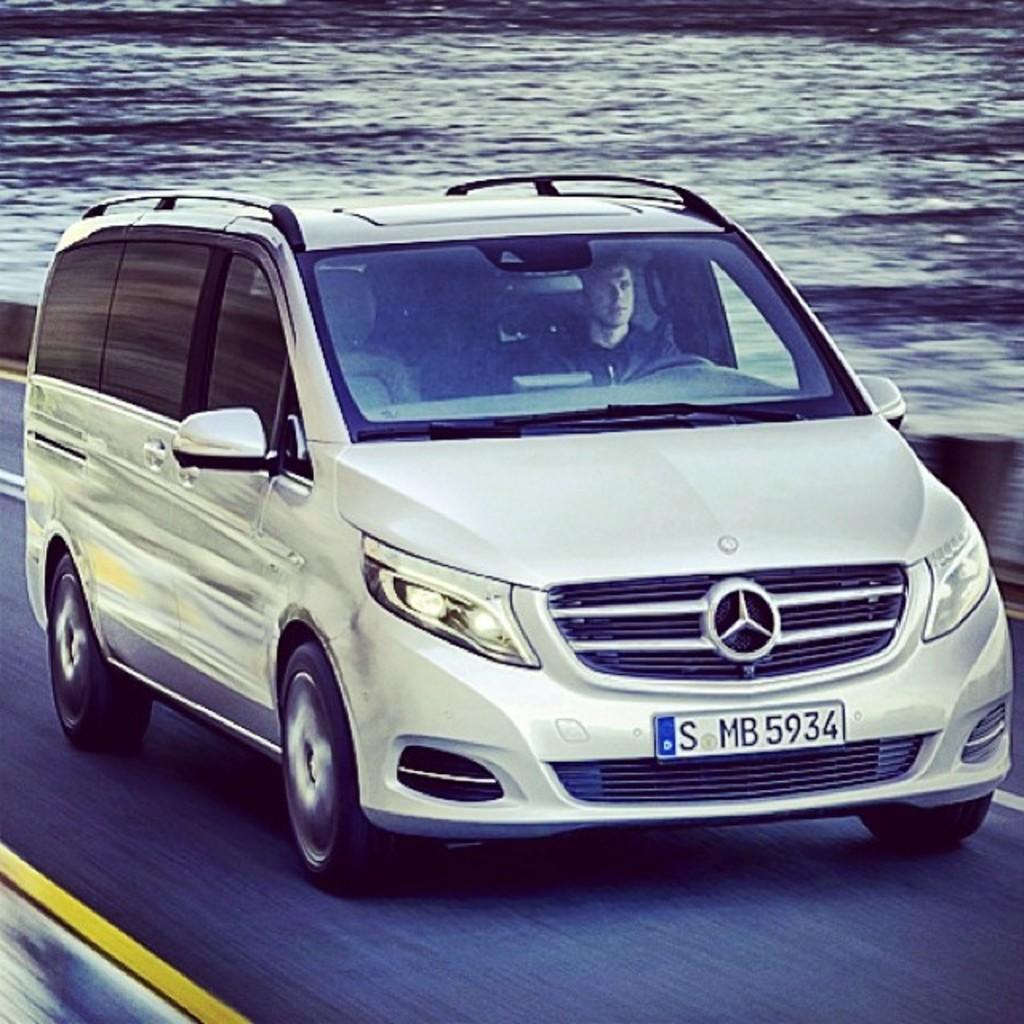What string of numbers and letters would you use to identify this car?
Give a very brief answer. S mb 5934. What kind of vehicle is this?
Provide a succinct answer. Mercedes. 